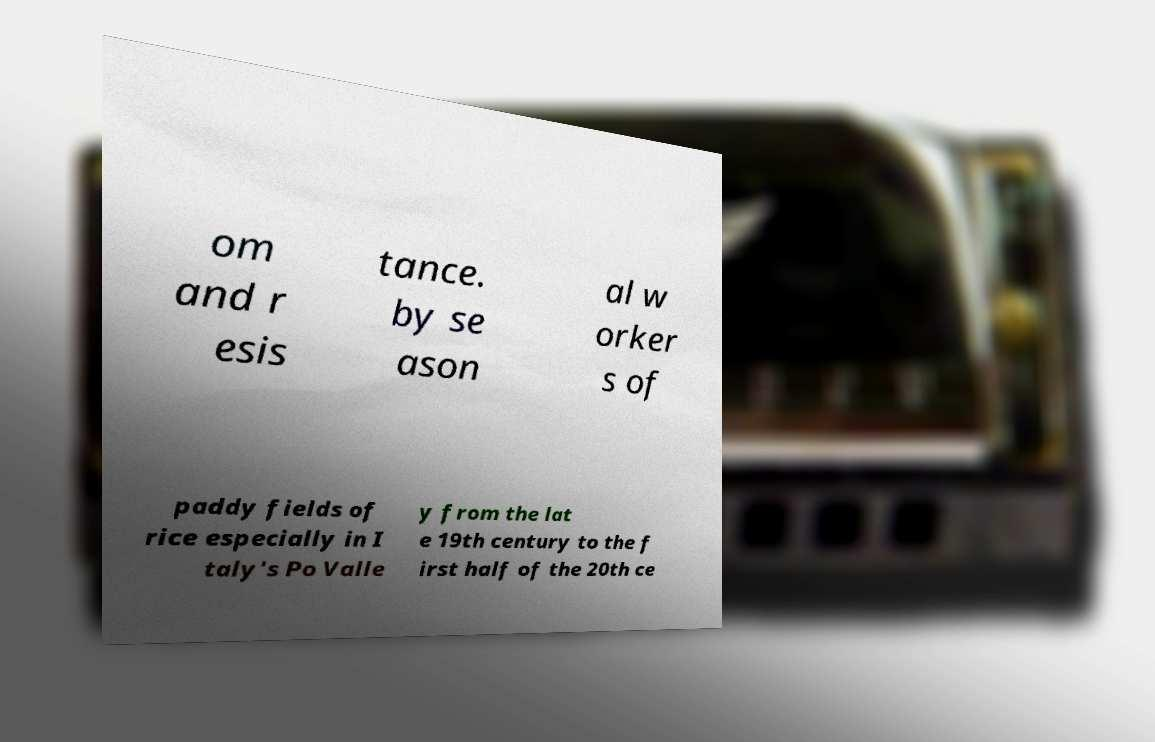What messages or text are displayed in this image? I need them in a readable, typed format. om and r esis tance. by se ason al w orker s of paddy fields of rice especially in I taly's Po Valle y from the lat e 19th century to the f irst half of the 20th ce 